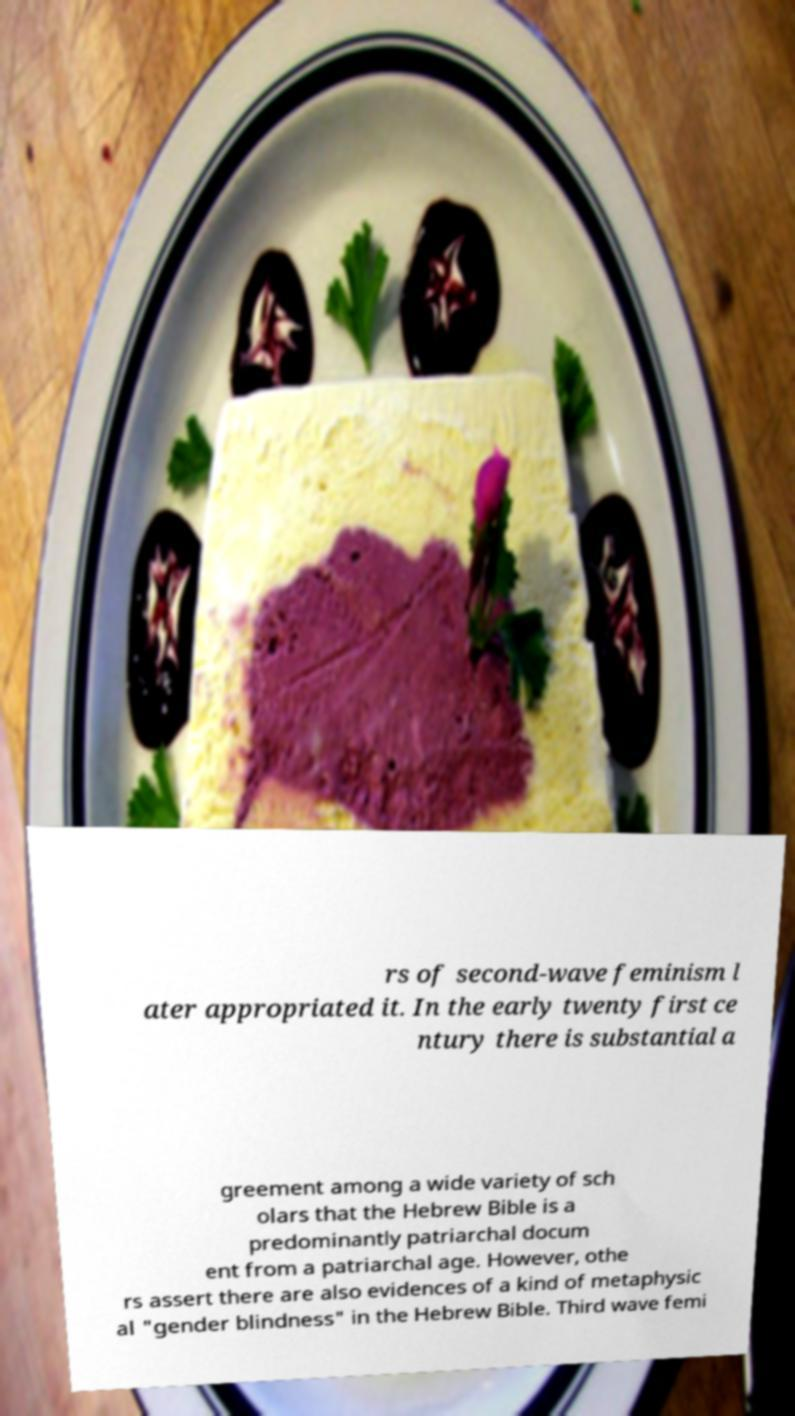Can you accurately transcribe the text from the provided image for me? rs of second-wave feminism l ater appropriated it. In the early twenty first ce ntury there is substantial a greement among a wide variety of sch olars that the Hebrew Bible is a predominantly patriarchal docum ent from a patriarchal age. However, othe rs assert there are also evidences of a kind of metaphysic al "gender blindness" in the Hebrew Bible. Third wave femi 